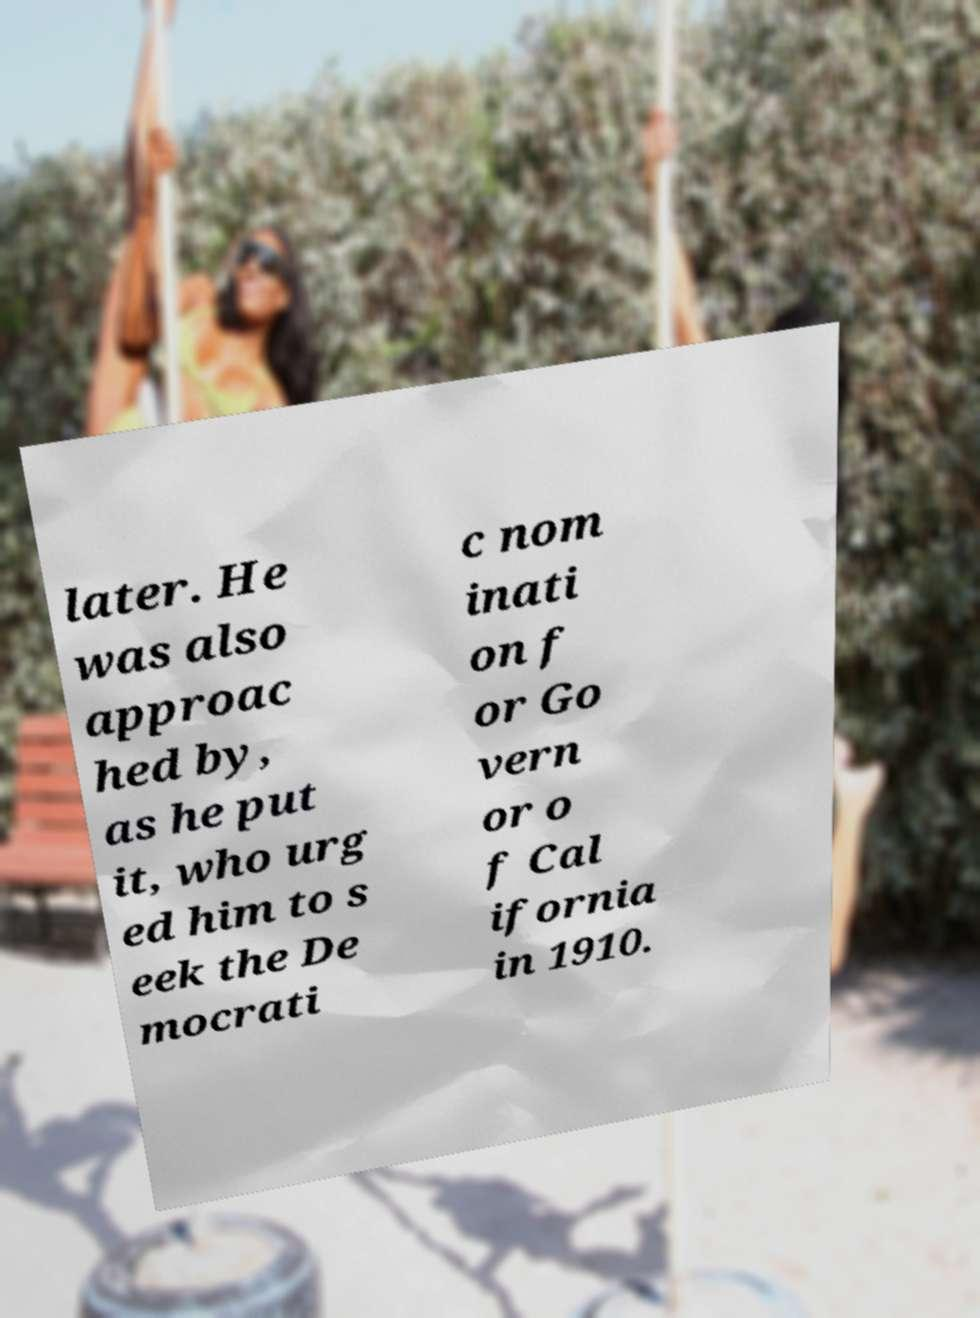Can you read and provide the text displayed in the image?This photo seems to have some interesting text. Can you extract and type it out for me? later. He was also approac hed by, as he put it, who urg ed him to s eek the De mocrati c nom inati on f or Go vern or o f Cal ifornia in 1910. 